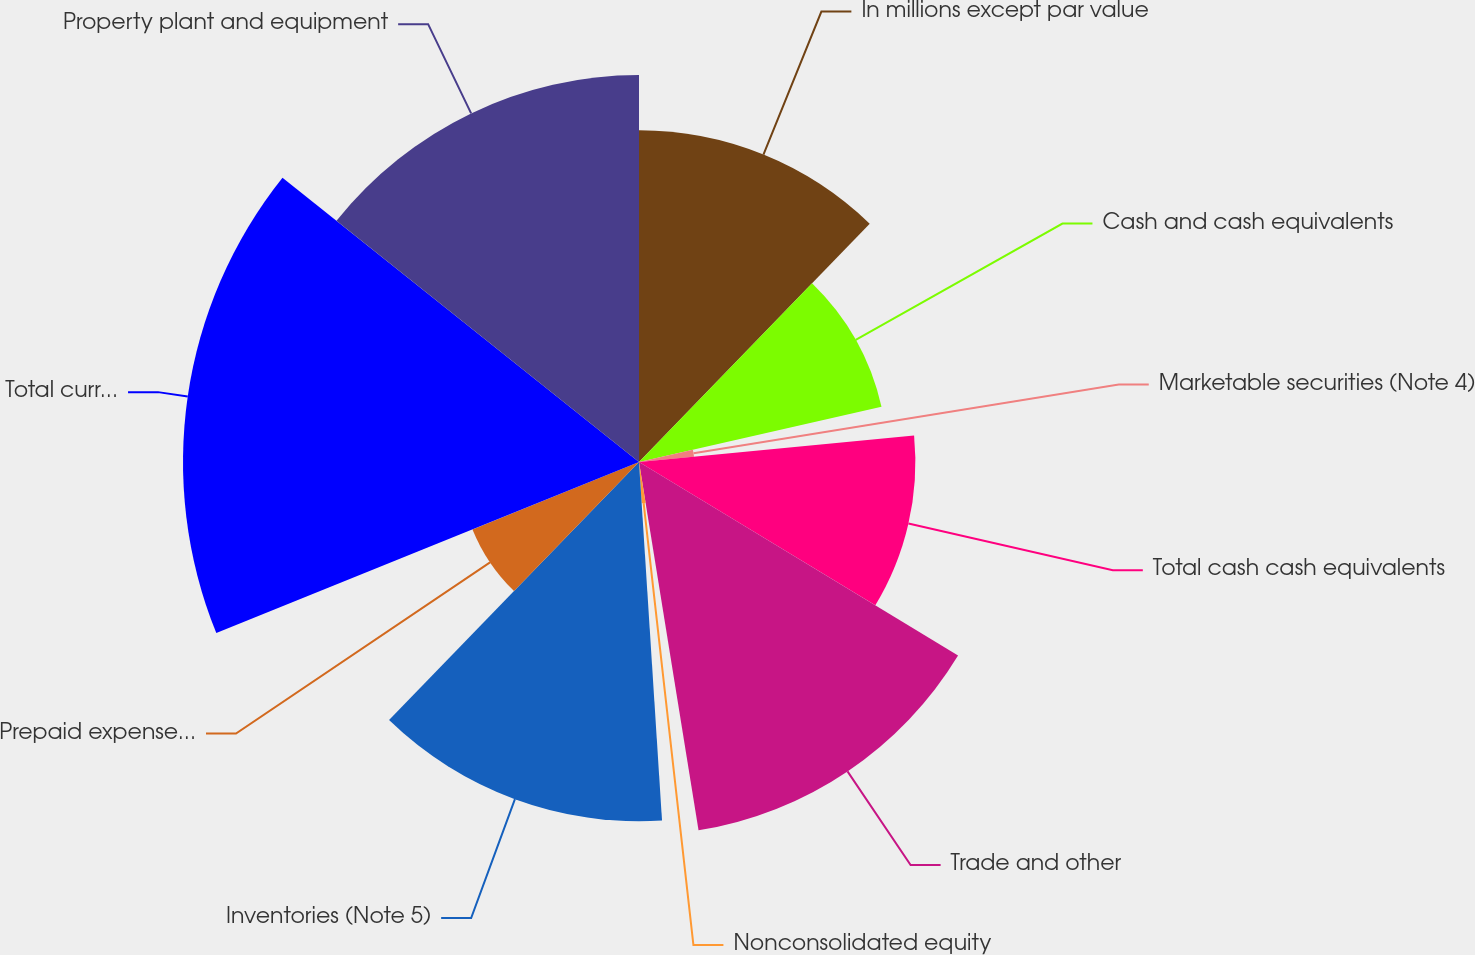<chart> <loc_0><loc_0><loc_500><loc_500><pie_chart><fcel>In millions except par value<fcel>Cash and cash equivalents<fcel>Marketable securities (Note 4)<fcel>Total cash cash equivalents<fcel>Trade and other<fcel>Nonconsolidated equity<fcel>Inventories (Note 5)<fcel>Prepaid expenses and other<fcel>Total current assets<fcel>Property plant and equipment<nl><fcel>12.24%<fcel>9.18%<fcel>2.04%<fcel>10.2%<fcel>13.77%<fcel>1.53%<fcel>13.26%<fcel>6.63%<fcel>16.83%<fcel>14.28%<nl></chart> 